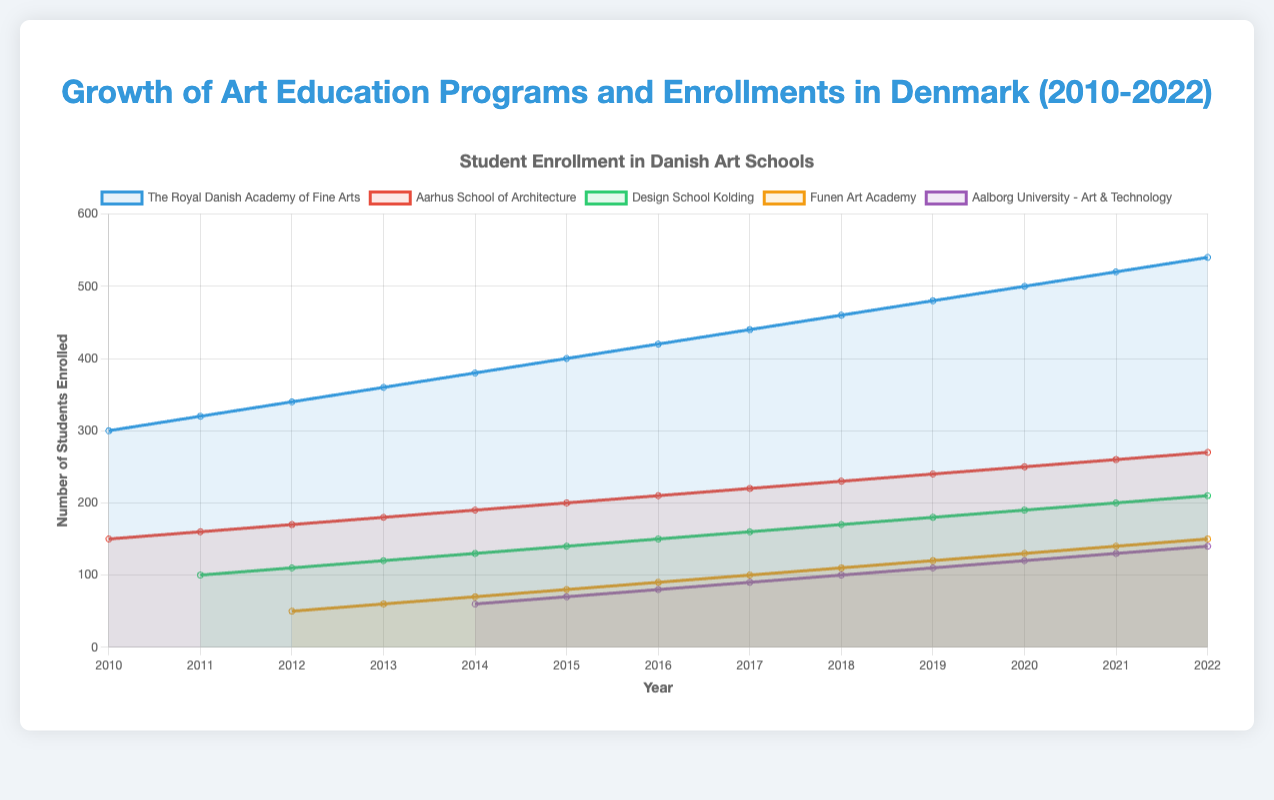How many students were enrolled in the The Royal Danish Academy of Fine Arts in 2016? According to the figure, The Royal Danish Academy of Fine Arts had 420 students enrolled in 2016.
Answer: 420 Which school had the highest enrollment in 2020? From the figure, it's clear that The Royal Danish Academy of Fine Arts had the highest enrollment with 500 students in 2020.
Answer: The Royal Danish Academy of Fine Arts What is the total number of programs offered by all schools in 2015? Summing up the programs offered in 2015: (13 from The Royal Danish Academy of Fine Arts) + (8 from Aarhus School of Architecture) + (7 from Design School Kolding) + (6 from Funen Art Academy) + (5 from Aalborg University - Art & Technology) = 39.
Answer: 39 How much did the enrollment at Aarhus School of Architecture increase from 2010 to 2022? In 2010, Aarhus School of Architecture had 150 students enrolled, and in 2022, it had 270. The increase is 270 - 150 = 120.
Answer: 120 Among the schools, which school consistently increased their enrollment every year from 2010 to 2022? By observing the figure, The Royal Danish Academy of Fine Arts shows a consistent increase in enrollment every year from 2010 (300 students) to 2022 (540 students).
Answer: The Royal Danish Academy of Fine Arts What is the average number of students enrolled in Funen Art Academy from 2012 to 2019? The total enrollment for Funen Art Academy from 2012 to 2019 is (50 + 60 + 70 + 80 + 90 + 100 + 110 + 120) = 680. There are 8 years, so the average is 680 / 8 = 85.
Answer: 85 Which year did Aalborg University - Art & Technology first appear in the figure? By looking at the visual data, Aalborg University - Art & Technology first appears in 2014.
Answer: 2014 What is the difference in the number of programs offered by The Royal Danish Academy of Fine Arts between 2010 and 2022? The Royal Danish Academy of Fine Arts offered 8 programs in 2010 and 20 programs in 2022. The difference is 20 - 8 = 12.
Answer: 12 Compare the student enrollments between Design School Kolding and Funen Art Academy in 2015. Which had more students and by how much? In 2015, Design School Kolding had 140 students enrolled, while Funen Art Academy had 80. The difference is 140 - 80 = 60, with Design School Kolding having more students.
Answer: Design School Kolding by 60 What can be inferred about the overall trend in student enrolment for the art schools from 2010 to 2022? The overall trend visible from the figure indicates a consistent increase in student enrolment across most of the art schools from 2010 to 2022, reflecting a growing interest in art-related education.
Answer: Consistent increase 